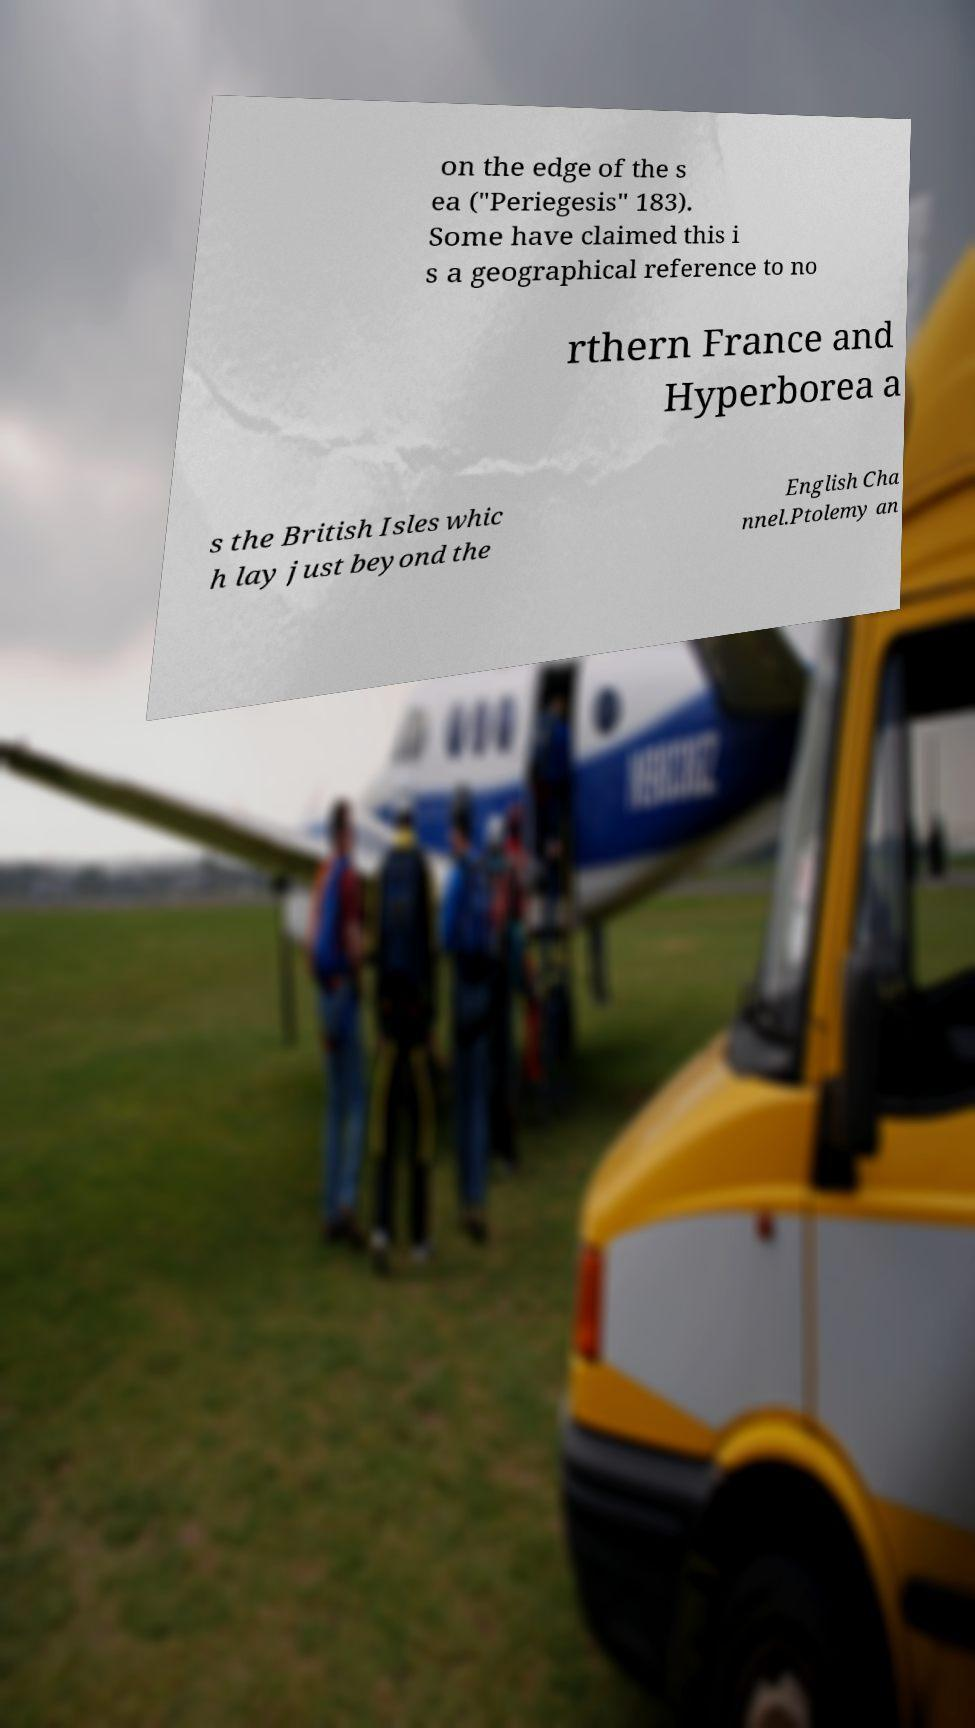Could you extract and type out the text from this image? on the edge of the s ea ("Periegesis" 183). Some have claimed this i s a geographical reference to no rthern France and Hyperborea a s the British Isles whic h lay just beyond the English Cha nnel.Ptolemy an 